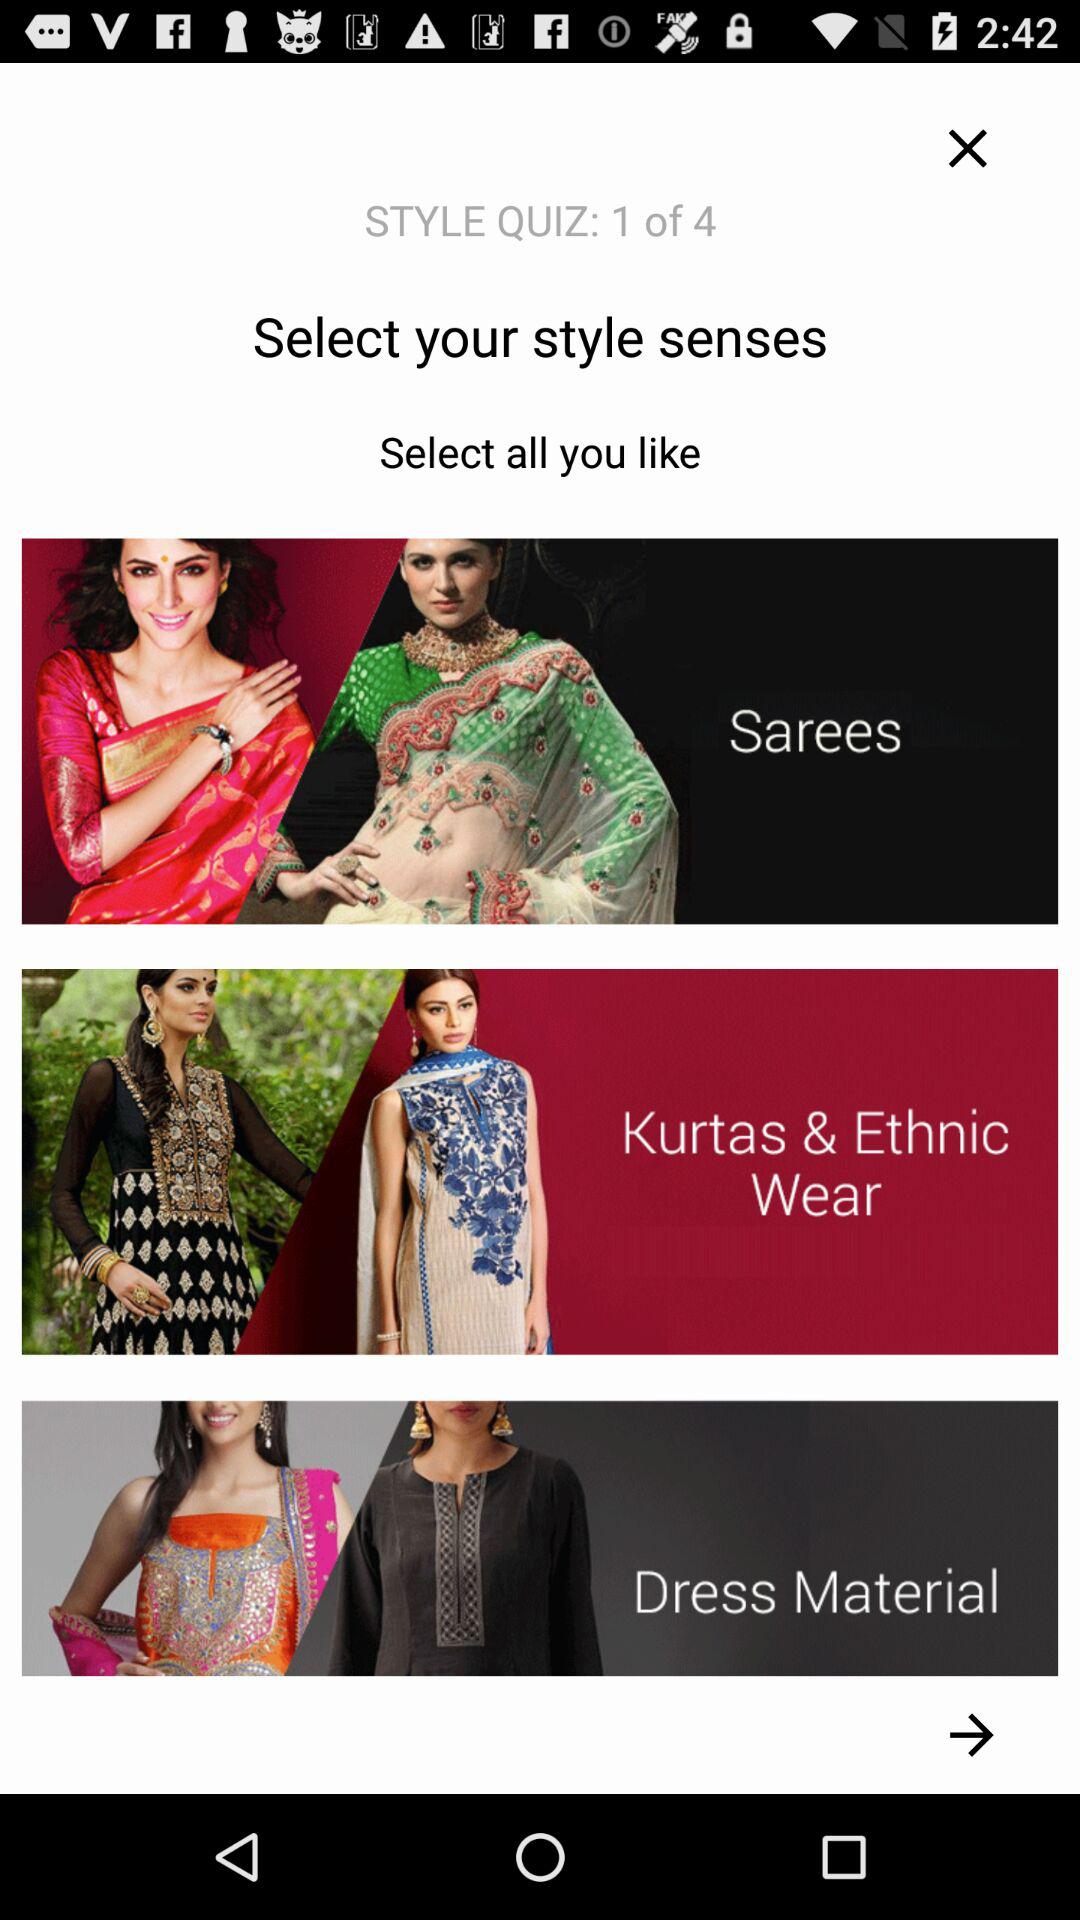How many questions are there in "STYLE QUIZ"? There are 4 questions in "STYLE QUIZ". 